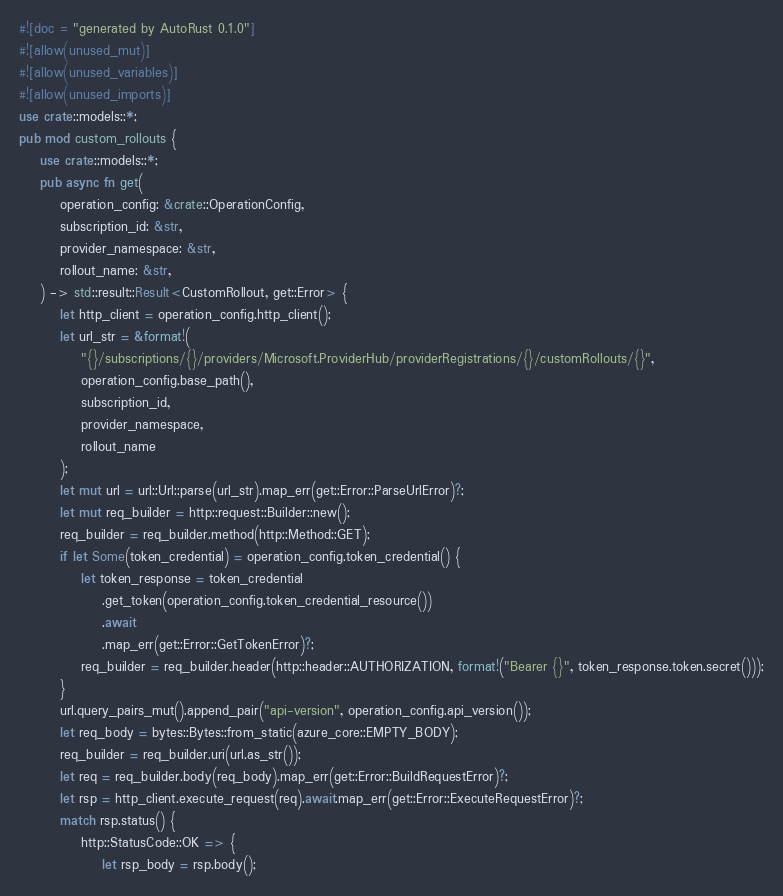Convert code to text. <code><loc_0><loc_0><loc_500><loc_500><_Rust_>#![doc = "generated by AutoRust 0.1.0"]
#![allow(unused_mut)]
#![allow(unused_variables)]
#![allow(unused_imports)]
use crate::models::*;
pub mod custom_rollouts {
    use crate::models::*;
    pub async fn get(
        operation_config: &crate::OperationConfig,
        subscription_id: &str,
        provider_namespace: &str,
        rollout_name: &str,
    ) -> std::result::Result<CustomRollout, get::Error> {
        let http_client = operation_config.http_client();
        let url_str = &format!(
            "{}/subscriptions/{}/providers/Microsoft.ProviderHub/providerRegistrations/{}/customRollouts/{}",
            operation_config.base_path(),
            subscription_id,
            provider_namespace,
            rollout_name
        );
        let mut url = url::Url::parse(url_str).map_err(get::Error::ParseUrlError)?;
        let mut req_builder = http::request::Builder::new();
        req_builder = req_builder.method(http::Method::GET);
        if let Some(token_credential) = operation_config.token_credential() {
            let token_response = token_credential
                .get_token(operation_config.token_credential_resource())
                .await
                .map_err(get::Error::GetTokenError)?;
            req_builder = req_builder.header(http::header::AUTHORIZATION, format!("Bearer {}", token_response.token.secret()));
        }
        url.query_pairs_mut().append_pair("api-version", operation_config.api_version());
        let req_body = bytes::Bytes::from_static(azure_core::EMPTY_BODY);
        req_builder = req_builder.uri(url.as_str());
        let req = req_builder.body(req_body).map_err(get::Error::BuildRequestError)?;
        let rsp = http_client.execute_request(req).await.map_err(get::Error::ExecuteRequestError)?;
        match rsp.status() {
            http::StatusCode::OK => {
                let rsp_body = rsp.body();</code> 